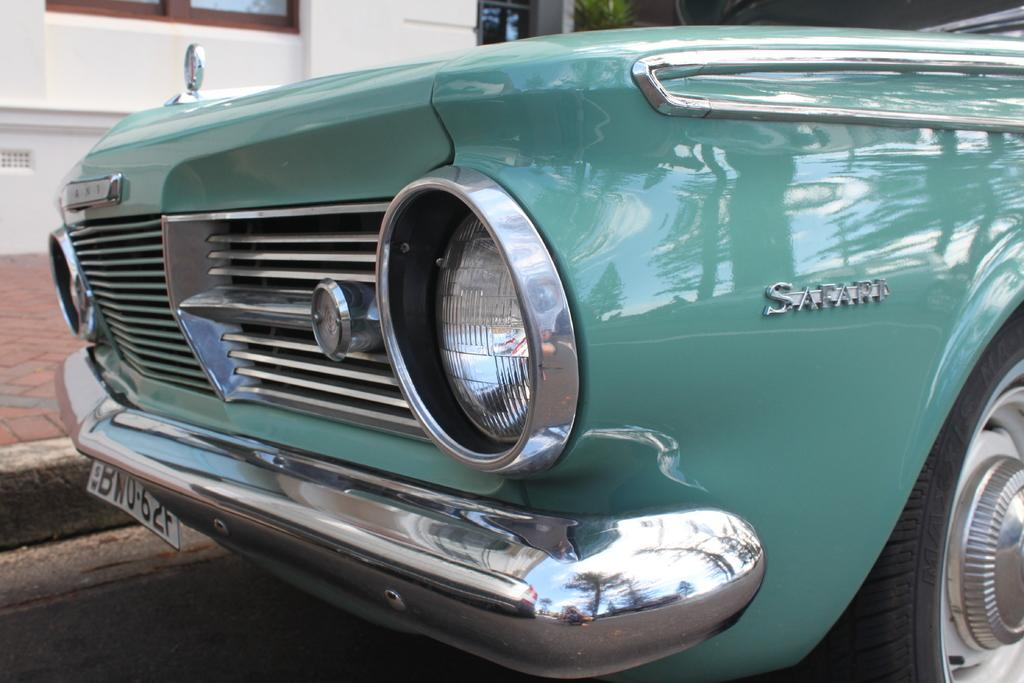What is the main subject of the image? There is a car in the image. What can be seen in the background of the image? There is a building in the background of the image. What is located at the bottom of the image? The bottom of the image contains a road. What organization is responsible for the point at the top of the car in the image? There is no organization mentioned in the image, and the car does not have a point at the top. 